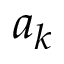<formula> <loc_0><loc_0><loc_500><loc_500>a _ { k }</formula> 